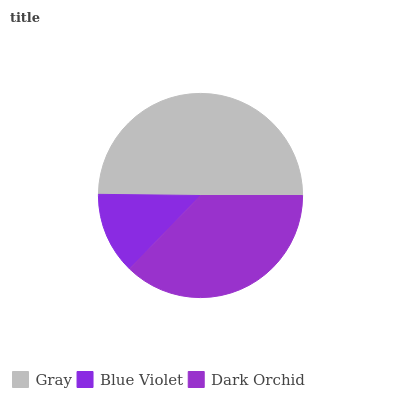Is Blue Violet the minimum?
Answer yes or no. Yes. Is Gray the maximum?
Answer yes or no. Yes. Is Dark Orchid the minimum?
Answer yes or no. No. Is Dark Orchid the maximum?
Answer yes or no. No. Is Dark Orchid greater than Blue Violet?
Answer yes or no. Yes. Is Blue Violet less than Dark Orchid?
Answer yes or no. Yes. Is Blue Violet greater than Dark Orchid?
Answer yes or no. No. Is Dark Orchid less than Blue Violet?
Answer yes or no. No. Is Dark Orchid the high median?
Answer yes or no. Yes. Is Dark Orchid the low median?
Answer yes or no. Yes. Is Gray the high median?
Answer yes or no. No. Is Gray the low median?
Answer yes or no. No. 